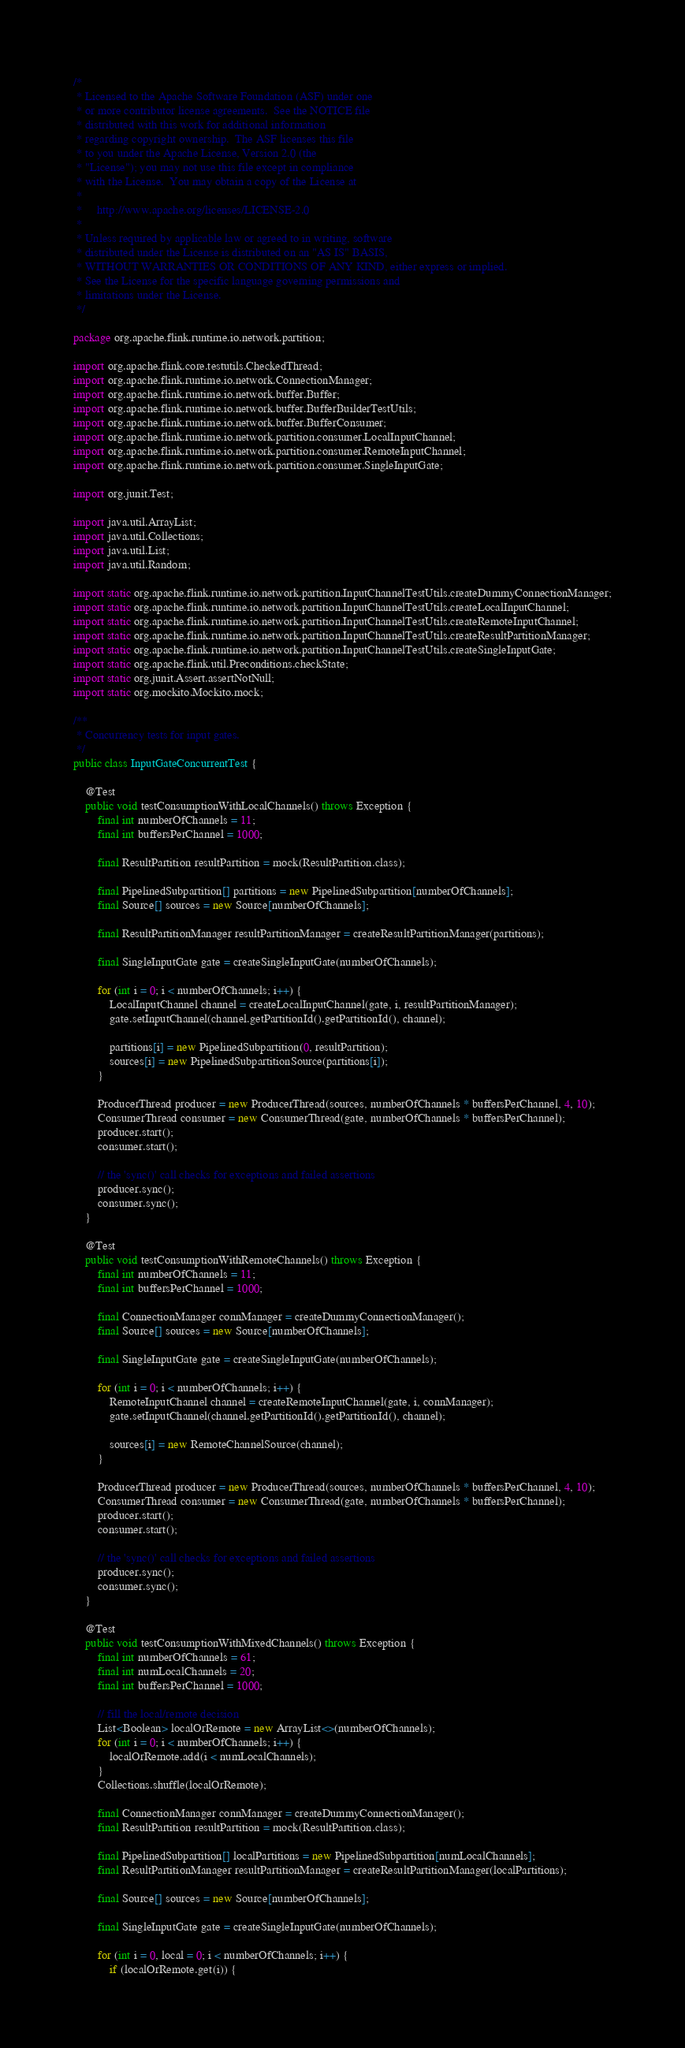<code> <loc_0><loc_0><loc_500><loc_500><_Java_>/*
 * Licensed to the Apache Software Foundation (ASF) under one
 * or more contributor license agreements.  See the NOTICE file
 * distributed with this work for additional information
 * regarding copyright ownership.  The ASF licenses this file
 * to you under the Apache License, Version 2.0 (the
 * "License"); you may not use this file except in compliance
 * with the License.  You may obtain a copy of the License at
 *
 *     http://www.apache.org/licenses/LICENSE-2.0
 *
 * Unless required by applicable law or agreed to in writing, software
 * distributed under the License is distributed on an "AS IS" BASIS,
 * WITHOUT WARRANTIES OR CONDITIONS OF ANY KIND, either express or implied.
 * See the License for the specific language governing permissions and
 * limitations under the License.
 */

package org.apache.flink.runtime.io.network.partition;

import org.apache.flink.core.testutils.CheckedThread;
import org.apache.flink.runtime.io.network.ConnectionManager;
import org.apache.flink.runtime.io.network.buffer.Buffer;
import org.apache.flink.runtime.io.network.buffer.BufferBuilderTestUtils;
import org.apache.flink.runtime.io.network.buffer.BufferConsumer;
import org.apache.flink.runtime.io.network.partition.consumer.LocalInputChannel;
import org.apache.flink.runtime.io.network.partition.consumer.RemoteInputChannel;
import org.apache.flink.runtime.io.network.partition.consumer.SingleInputGate;

import org.junit.Test;

import java.util.ArrayList;
import java.util.Collections;
import java.util.List;
import java.util.Random;

import static org.apache.flink.runtime.io.network.partition.InputChannelTestUtils.createDummyConnectionManager;
import static org.apache.flink.runtime.io.network.partition.InputChannelTestUtils.createLocalInputChannel;
import static org.apache.flink.runtime.io.network.partition.InputChannelTestUtils.createRemoteInputChannel;
import static org.apache.flink.runtime.io.network.partition.InputChannelTestUtils.createResultPartitionManager;
import static org.apache.flink.runtime.io.network.partition.InputChannelTestUtils.createSingleInputGate;
import static org.apache.flink.util.Preconditions.checkState;
import static org.junit.Assert.assertNotNull;
import static org.mockito.Mockito.mock;

/**
 * Concurrency tests for input gates.
 */
public class InputGateConcurrentTest {

	@Test
	public void testConsumptionWithLocalChannels() throws Exception {
		final int numberOfChannels = 11;
		final int buffersPerChannel = 1000;

		final ResultPartition resultPartition = mock(ResultPartition.class);

		final PipelinedSubpartition[] partitions = new PipelinedSubpartition[numberOfChannels];
		final Source[] sources = new Source[numberOfChannels];

		final ResultPartitionManager resultPartitionManager = createResultPartitionManager(partitions);

		final SingleInputGate gate = createSingleInputGate(numberOfChannels);

		for (int i = 0; i < numberOfChannels; i++) {
			LocalInputChannel channel = createLocalInputChannel(gate, i, resultPartitionManager);
			gate.setInputChannel(channel.getPartitionId().getPartitionId(), channel);

			partitions[i] = new PipelinedSubpartition(0, resultPartition);
			sources[i] = new PipelinedSubpartitionSource(partitions[i]);
		}

		ProducerThread producer = new ProducerThread(sources, numberOfChannels * buffersPerChannel, 4, 10);
		ConsumerThread consumer = new ConsumerThread(gate, numberOfChannels * buffersPerChannel);
		producer.start();
		consumer.start();

		// the 'sync()' call checks for exceptions and failed assertions
		producer.sync();
		consumer.sync();
	}

	@Test
	public void testConsumptionWithRemoteChannels() throws Exception {
		final int numberOfChannels = 11;
		final int buffersPerChannel = 1000;

		final ConnectionManager connManager = createDummyConnectionManager();
		final Source[] sources = new Source[numberOfChannels];

		final SingleInputGate gate = createSingleInputGate(numberOfChannels);

		for (int i = 0; i < numberOfChannels; i++) {
			RemoteInputChannel channel = createRemoteInputChannel(gate, i, connManager);
			gate.setInputChannel(channel.getPartitionId().getPartitionId(), channel);

			sources[i] = new RemoteChannelSource(channel);
		}

		ProducerThread producer = new ProducerThread(sources, numberOfChannels * buffersPerChannel, 4, 10);
		ConsumerThread consumer = new ConsumerThread(gate, numberOfChannels * buffersPerChannel);
		producer.start();
		consumer.start();

		// the 'sync()' call checks for exceptions and failed assertions
		producer.sync();
		consumer.sync();
	}

	@Test
	public void testConsumptionWithMixedChannels() throws Exception {
		final int numberOfChannels = 61;
		final int numLocalChannels = 20;
		final int buffersPerChannel = 1000;

		// fill the local/remote decision
		List<Boolean> localOrRemote = new ArrayList<>(numberOfChannels);
		for (int i = 0; i < numberOfChannels; i++) {
			localOrRemote.add(i < numLocalChannels);
		}
		Collections.shuffle(localOrRemote);

		final ConnectionManager connManager = createDummyConnectionManager();
		final ResultPartition resultPartition = mock(ResultPartition.class);

		final PipelinedSubpartition[] localPartitions = new PipelinedSubpartition[numLocalChannels];
		final ResultPartitionManager resultPartitionManager = createResultPartitionManager(localPartitions);

		final Source[] sources = new Source[numberOfChannels];

		final SingleInputGate gate = createSingleInputGate(numberOfChannels);

		for (int i = 0, local = 0; i < numberOfChannels; i++) {
			if (localOrRemote.get(i)) {</code> 